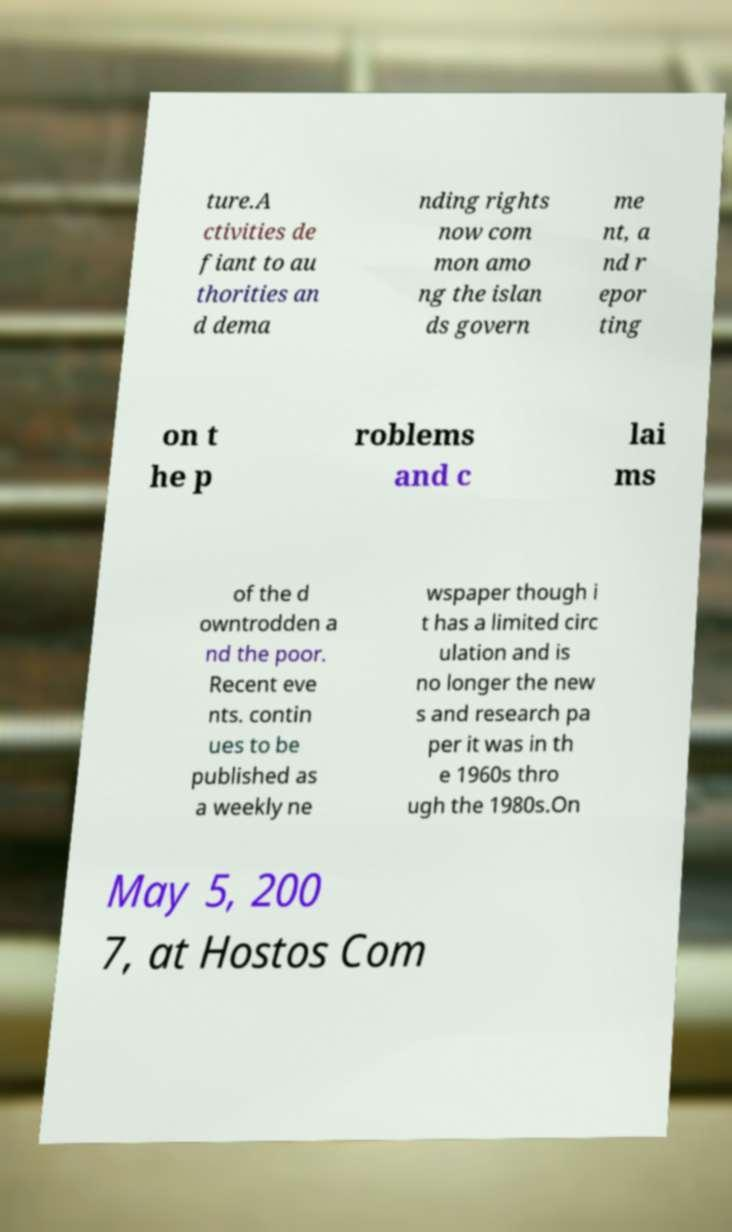Can you accurately transcribe the text from the provided image for me? ture.A ctivities de fiant to au thorities an d dema nding rights now com mon amo ng the islan ds govern me nt, a nd r epor ting on t he p roblems and c lai ms of the d owntrodden a nd the poor. Recent eve nts. contin ues to be published as a weekly ne wspaper though i t has a limited circ ulation and is no longer the new s and research pa per it was in th e 1960s thro ugh the 1980s.On May 5, 200 7, at Hostos Com 